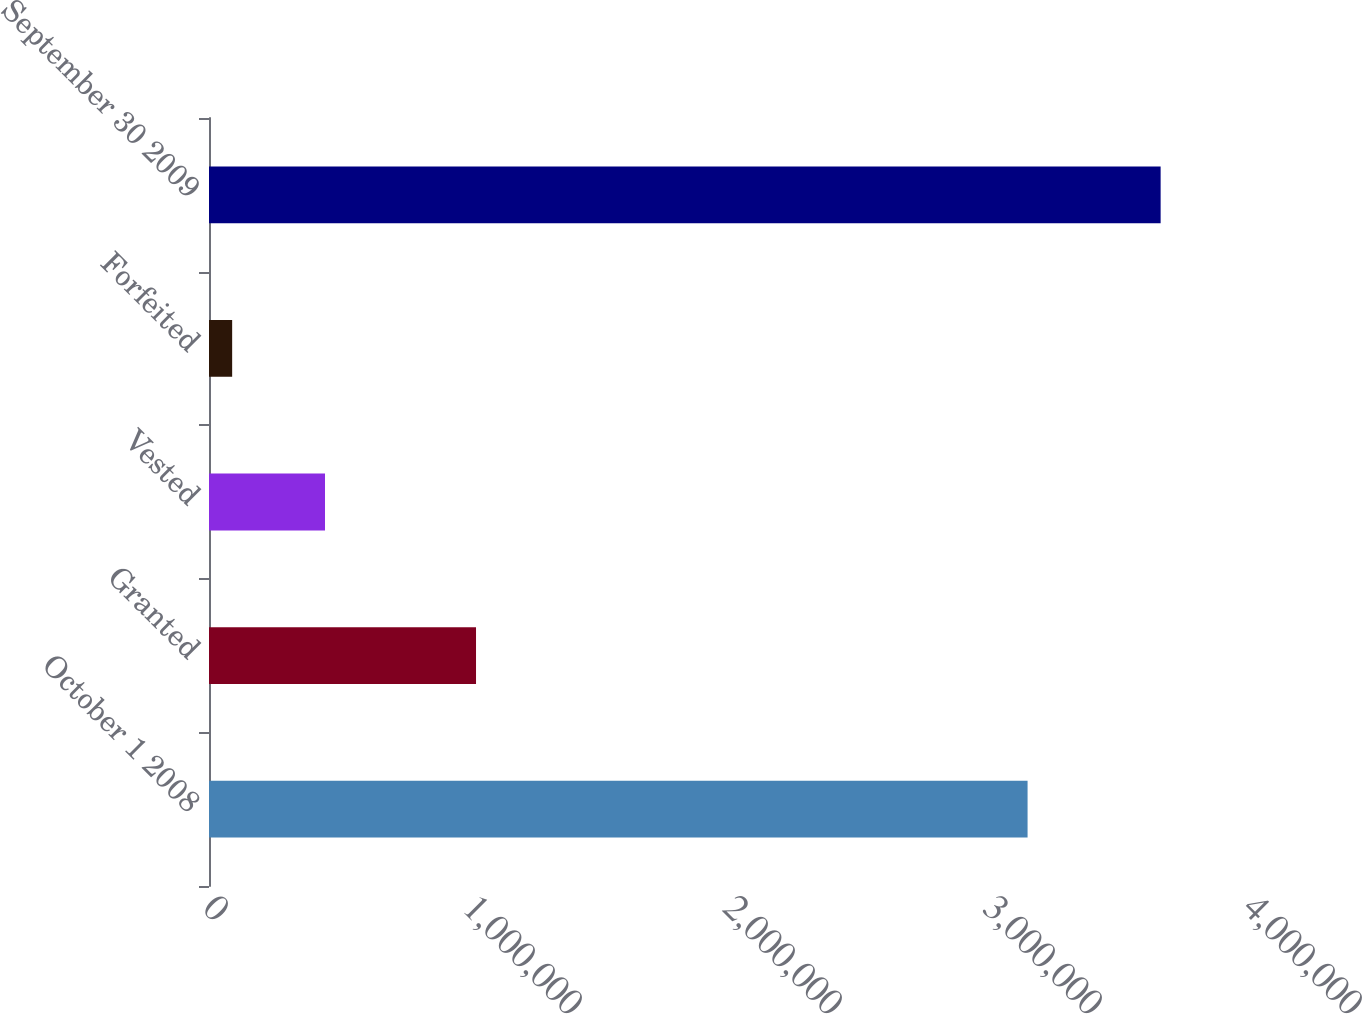<chart> <loc_0><loc_0><loc_500><loc_500><bar_chart><fcel>October 1 2008<fcel>Granted<fcel>Vested<fcel>Forfeited<fcel>September 30 2009<nl><fcel>3.14835e+06<fcel>1.027e+06<fcel>446169<fcel>89064<fcel>3.66011e+06<nl></chart> 